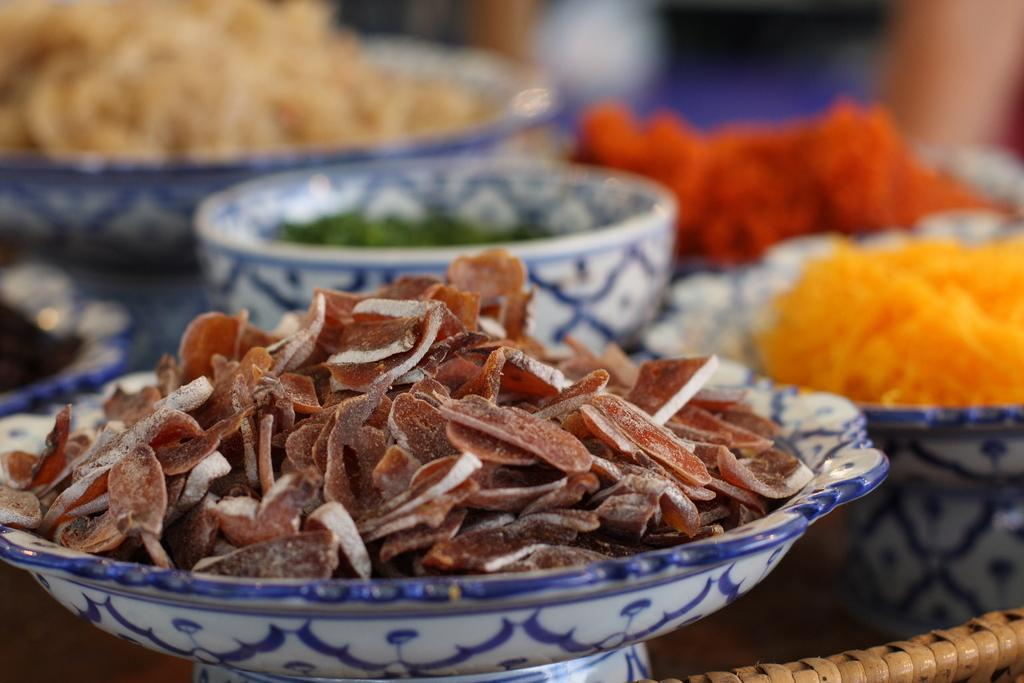What is present in the image related to food? There is food in the image. How are the food items arranged or contained? The food is in bowls. Where are the bowls of food located? The bowls are placed on a table. What type of animals can be seen at the zoo in the image? There is no zoo or animals present in the image; it features food in bowls placed on a table. 